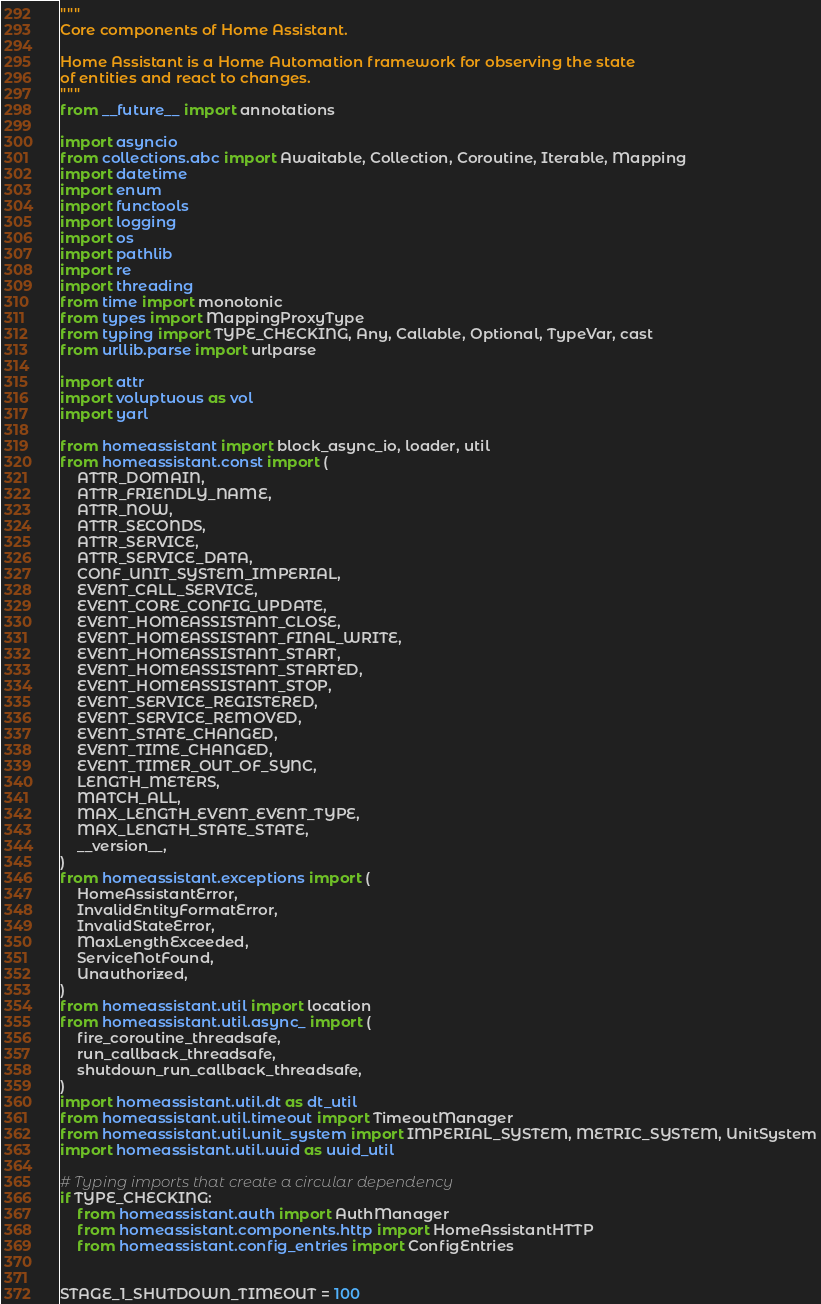<code> <loc_0><loc_0><loc_500><loc_500><_Python_>"""
Core components of Home Assistant.

Home Assistant is a Home Automation framework for observing the state
of entities and react to changes.
"""
from __future__ import annotations

import asyncio
from collections.abc import Awaitable, Collection, Coroutine, Iterable, Mapping
import datetime
import enum
import functools
import logging
import os
import pathlib
import re
import threading
from time import monotonic
from types import MappingProxyType
from typing import TYPE_CHECKING, Any, Callable, Optional, TypeVar, cast
from urllib.parse import urlparse

import attr
import voluptuous as vol
import yarl

from homeassistant import block_async_io, loader, util
from homeassistant.const import (
    ATTR_DOMAIN,
    ATTR_FRIENDLY_NAME,
    ATTR_NOW,
    ATTR_SECONDS,
    ATTR_SERVICE,
    ATTR_SERVICE_DATA,
    CONF_UNIT_SYSTEM_IMPERIAL,
    EVENT_CALL_SERVICE,
    EVENT_CORE_CONFIG_UPDATE,
    EVENT_HOMEASSISTANT_CLOSE,
    EVENT_HOMEASSISTANT_FINAL_WRITE,
    EVENT_HOMEASSISTANT_START,
    EVENT_HOMEASSISTANT_STARTED,
    EVENT_HOMEASSISTANT_STOP,
    EVENT_SERVICE_REGISTERED,
    EVENT_SERVICE_REMOVED,
    EVENT_STATE_CHANGED,
    EVENT_TIME_CHANGED,
    EVENT_TIMER_OUT_OF_SYNC,
    LENGTH_METERS,
    MATCH_ALL,
    MAX_LENGTH_EVENT_EVENT_TYPE,
    MAX_LENGTH_STATE_STATE,
    __version__,
)
from homeassistant.exceptions import (
    HomeAssistantError,
    InvalidEntityFormatError,
    InvalidStateError,
    MaxLengthExceeded,
    ServiceNotFound,
    Unauthorized,
)
from homeassistant.util import location
from homeassistant.util.async_ import (
    fire_coroutine_threadsafe,
    run_callback_threadsafe,
    shutdown_run_callback_threadsafe,
)
import homeassistant.util.dt as dt_util
from homeassistant.util.timeout import TimeoutManager
from homeassistant.util.unit_system import IMPERIAL_SYSTEM, METRIC_SYSTEM, UnitSystem
import homeassistant.util.uuid as uuid_util

# Typing imports that create a circular dependency
if TYPE_CHECKING:
    from homeassistant.auth import AuthManager
    from homeassistant.components.http import HomeAssistantHTTP
    from homeassistant.config_entries import ConfigEntries


STAGE_1_SHUTDOWN_TIMEOUT = 100</code> 